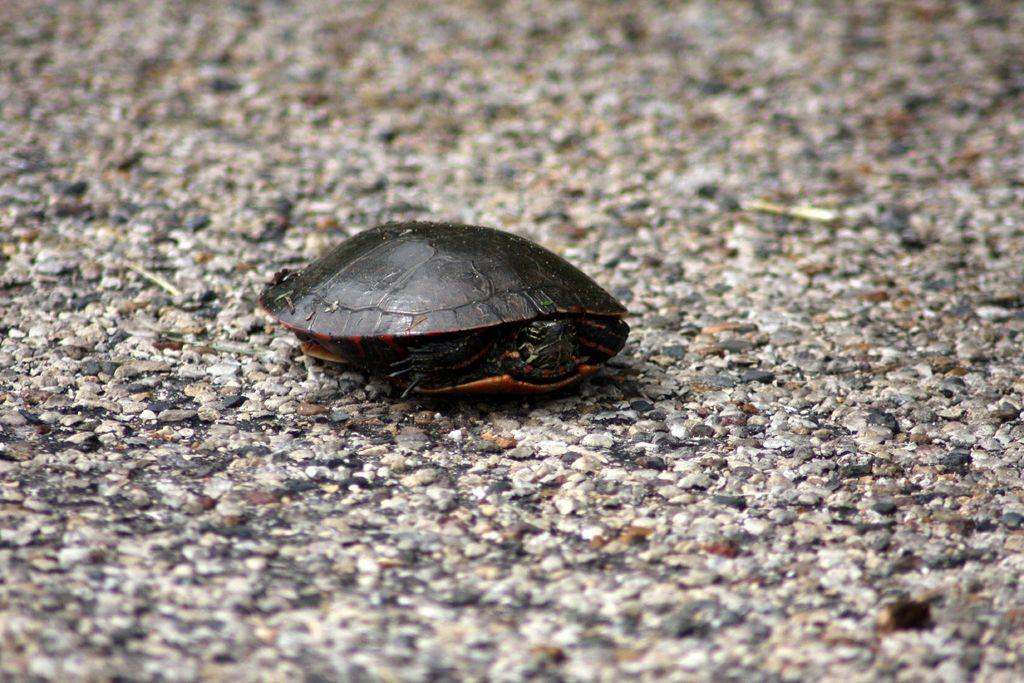What type of animal is present in the image? There is a tortoise in the image. Can you describe the tortoise's appearance? The tortoise has a hard shell and four legs. What might the tortoise be doing in the image? The tortoise's activity cannot be determined from the image alone. What color is the balloon that the tortoise is holding in the image? There is no balloon present in the image; it only features a tortoise. 